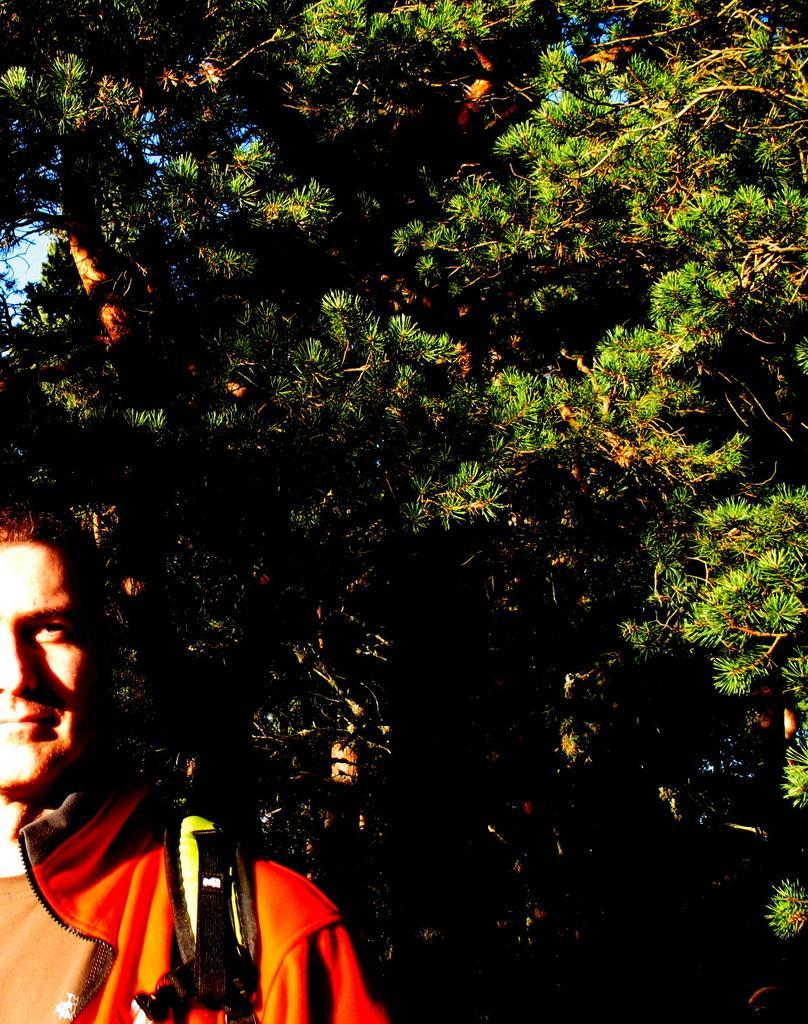Could you give a brief overview of what you see in this image? In this image we can see a person at the bottom right corner of the image and looks like he is wearing a bag, behind him there are trees. 